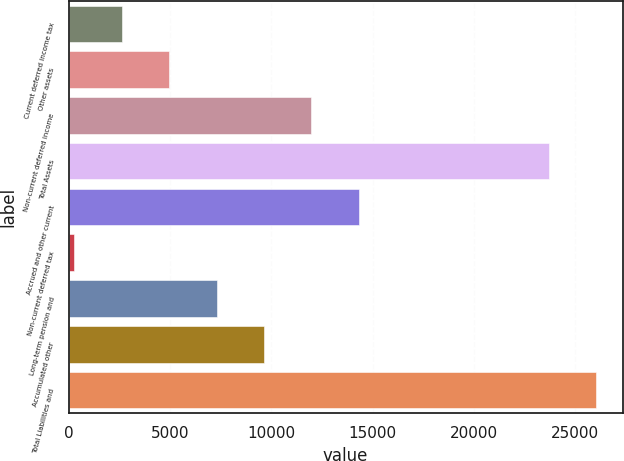<chart> <loc_0><loc_0><loc_500><loc_500><bar_chart><fcel>Current deferred income tax<fcel>Other assets<fcel>Non-current deferred income<fcel>Total Assets<fcel>Accrued and other current<fcel>Non-current deferred tax<fcel>Long-term pension and<fcel>Accumulated other<fcel>Total Liabilities and<nl><fcel>2612.7<fcel>4954.4<fcel>11979.5<fcel>23688<fcel>14321.2<fcel>271<fcel>7296.1<fcel>9637.8<fcel>26029.7<nl></chart> 